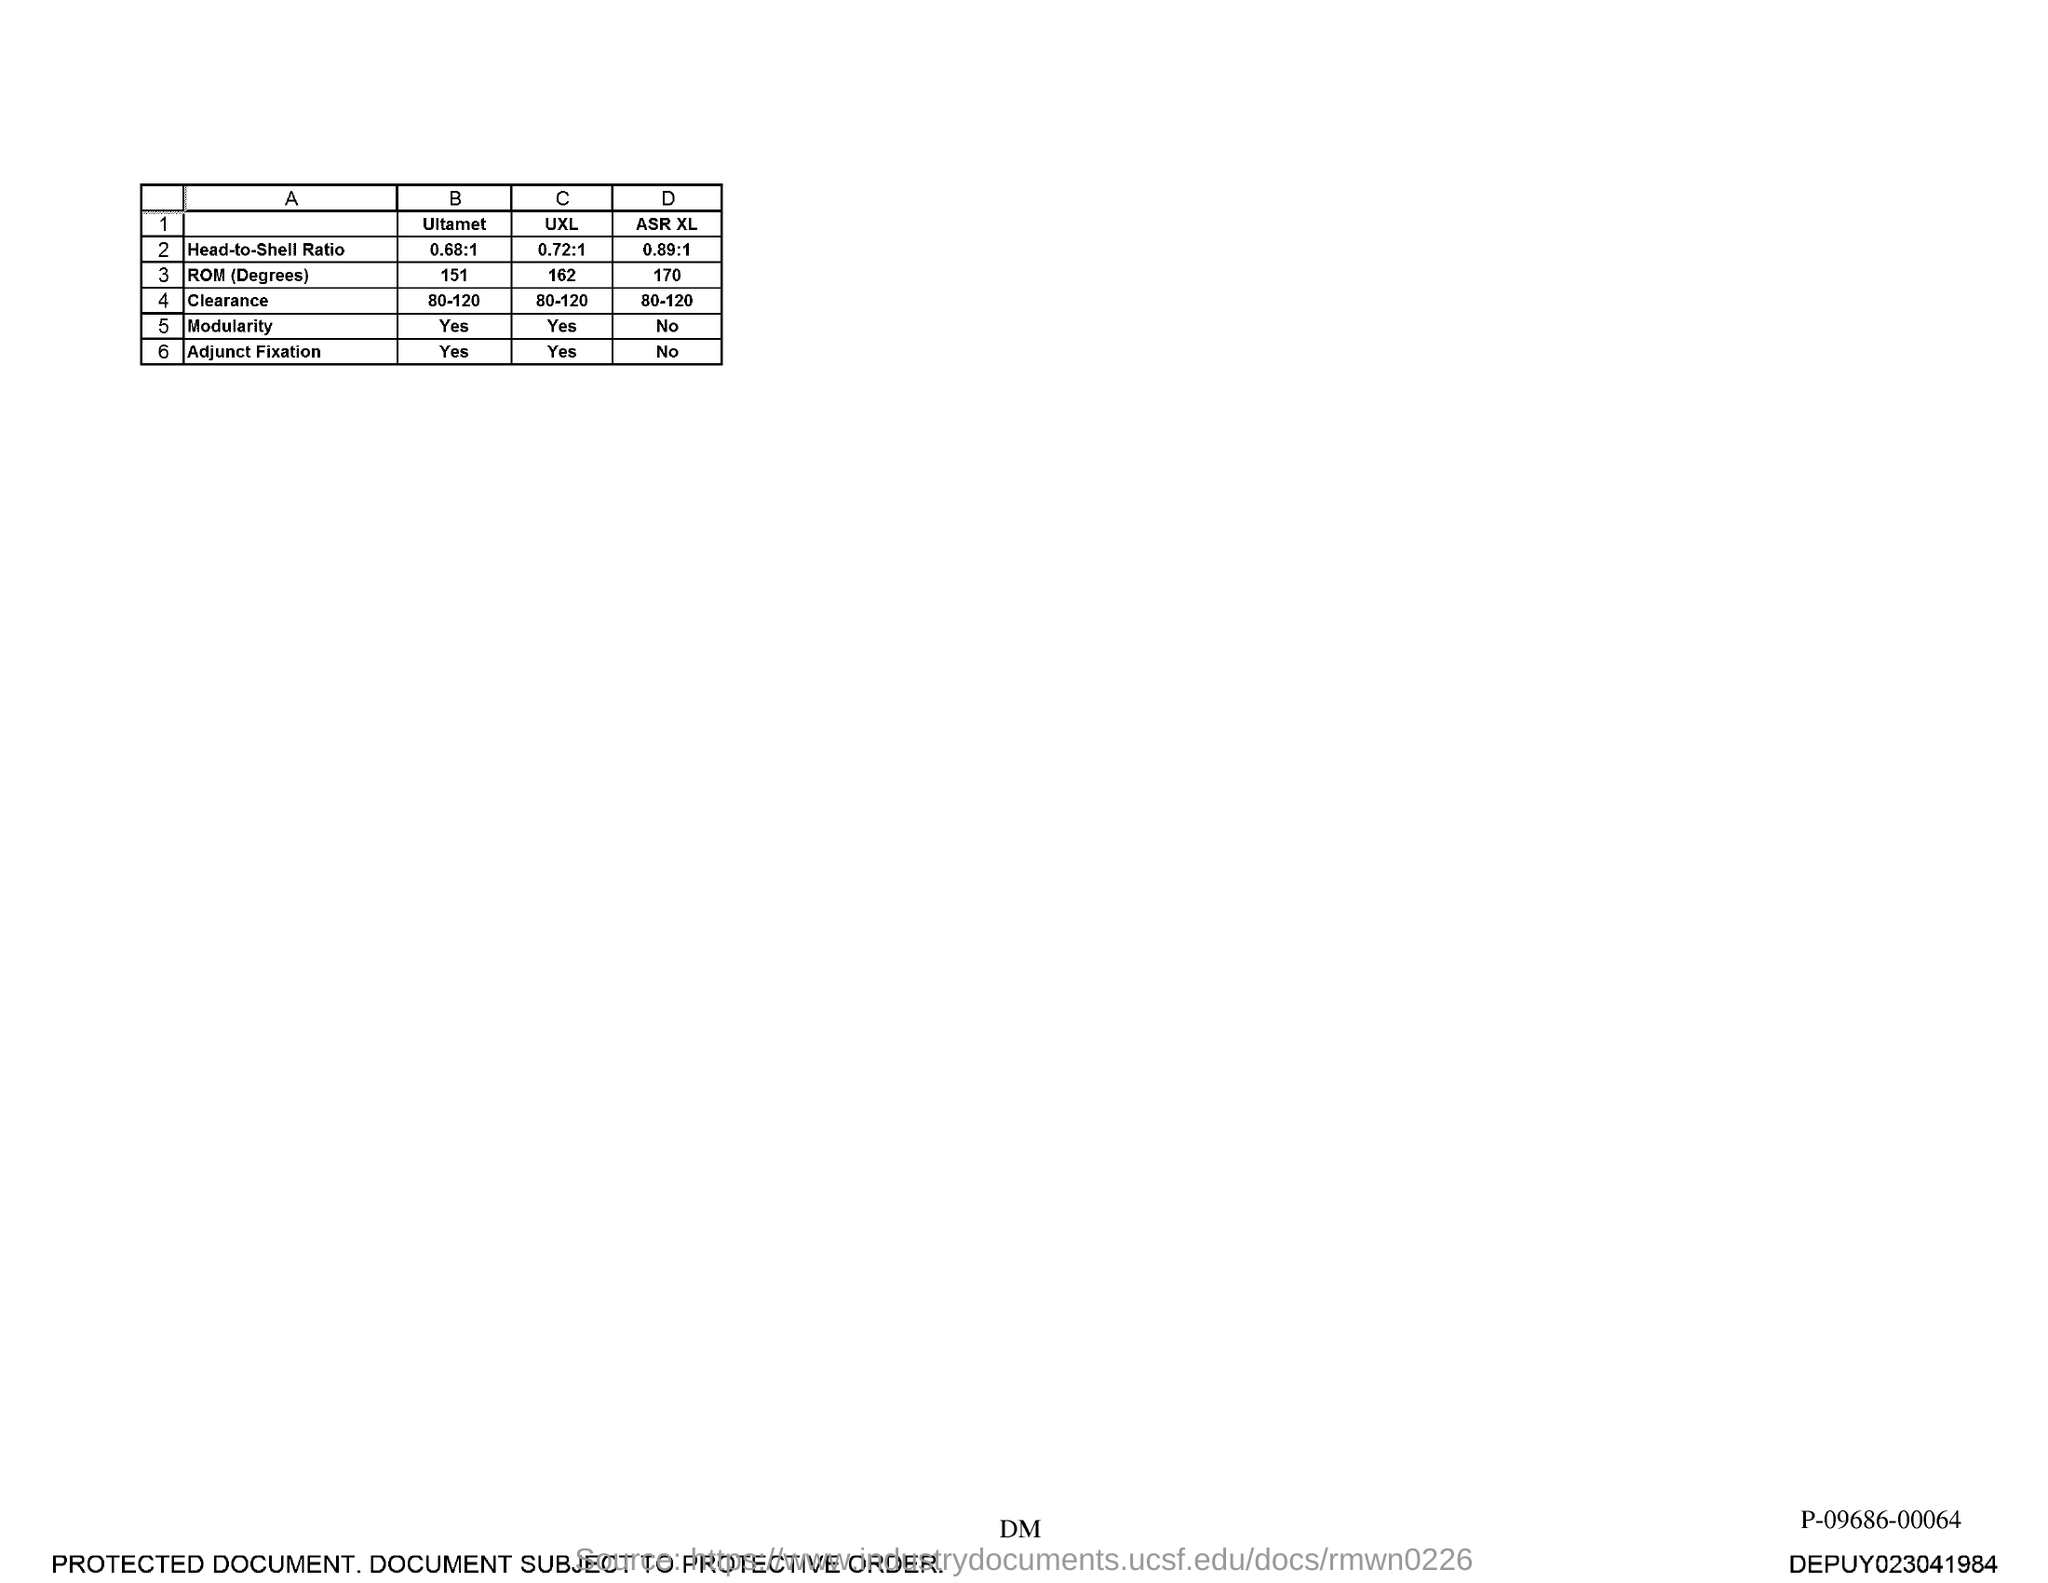What is the Head-to-Shell Ratio of Ultamet?
Keep it short and to the point. 0.68:1. What is the Head-to-Shell Ratio of UXL?
Offer a terse response. 0.72:1. 